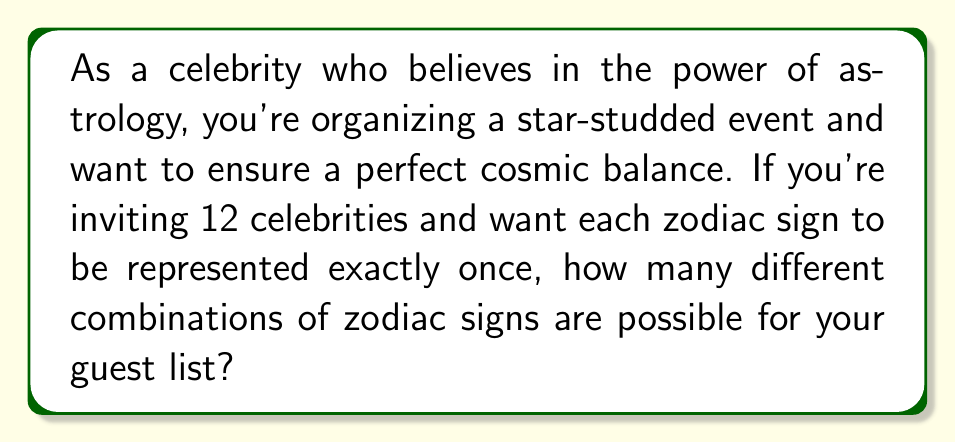Could you help me with this problem? Let's approach this step-by-step:

1) We have 12 celebrities and 12 zodiac signs. Each celebrity needs to be assigned a unique zodiac sign.

2) This scenario is equivalent to arranging 12 distinct items (zodiac signs) in 12 distinct positions (celebrities).

3) In combinatorics, this is known as a permutation of 12 items.

4) The formula for permutations of n distinct objects is:

   $$P(n) = n!$$

   Where $n!$ represents the factorial of n.

5) In this case, $n = 12$, so we need to calculate $12!$

6) Let's expand this:

   $$12! = 12 \times 11 \times 10 \times 9 \times 8 \times 7 \times 6 \times 5 \times 4 \times 3 \times 2 \times 1$$

7) Multiplying these numbers:

   $$12! = 479,001,600$$

Therefore, there are 479,001,600 different ways to assign the 12 zodiac signs to your 12 celebrity guests.
Answer: $479,001,600$ 